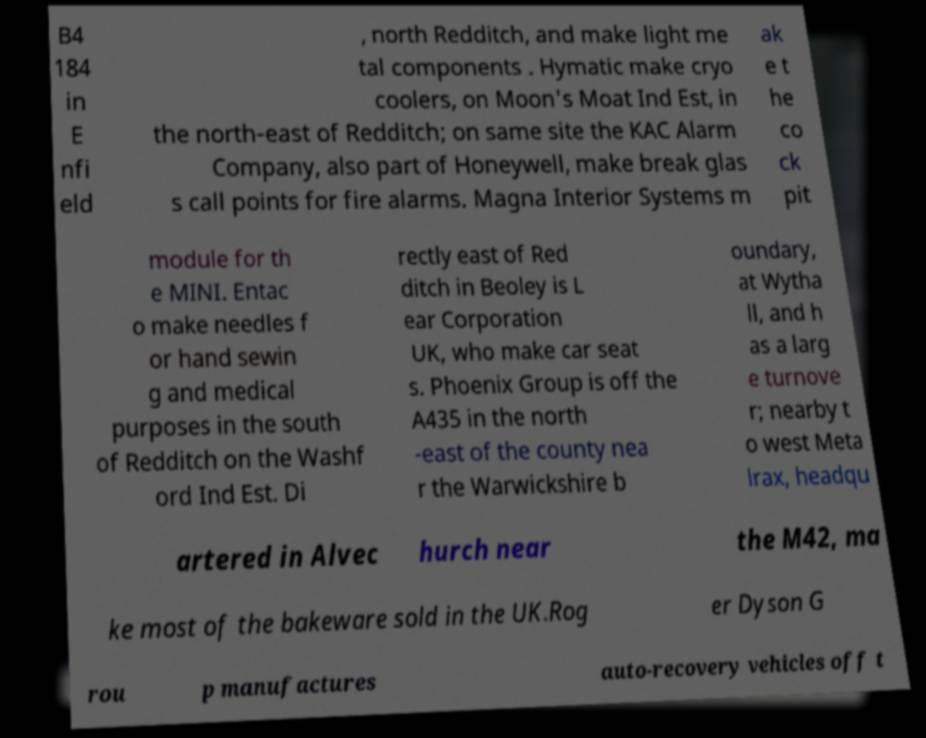There's text embedded in this image that I need extracted. Can you transcribe it verbatim? B4 184 in E nfi eld , north Redditch, and make light me tal components . Hymatic make cryo coolers, on Moon's Moat Ind Est, in the north-east of Redditch; on same site the KAC Alarm Company, also part of Honeywell, make break glas s call points for fire alarms. Magna Interior Systems m ak e t he co ck pit module for th e MINI. Entac o make needles f or hand sewin g and medical purposes in the south of Redditch on the Washf ord Ind Est. Di rectly east of Red ditch in Beoley is L ear Corporation UK, who make car seat s. Phoenix Group is off the A435 in the north -east of the county nea r the Warwickshire b oundary, at Wytha ll, and h as a larg e turnove r; nearby t o west Meta lrax, headqu artered in Alvec hurch near the M42, ma ke most of the bakeware sold in the UK.Rog er Dyson G rou p manufactures auto-recovery vehicles off t 